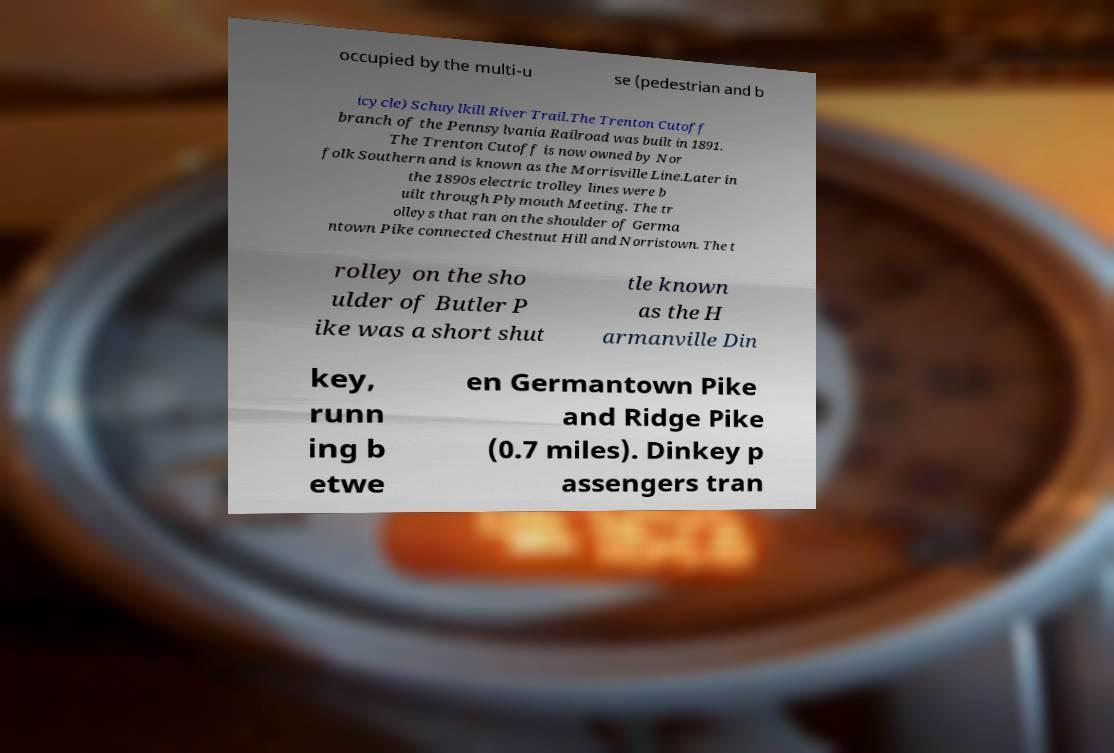I need the written content from this picture converted into text. Can you do that? occupied by the multi-u se (pedestrian and b icycle) Schuylkill River Trail.The Trenton Cutoff branch of the Pennsylvania Railroad was built in 1891. The Trenton Cutoff is now owned by Nor folk Southern and is known as the Morrisville Line.Later in the 1890s electric trolley lines were b uilt through Plymouth Meeting. The tr olleys that ran on the shoulder of Germa ntown Pike connected Chestnut Hill and Norristown. The t rolley on the sho ulder of Butler P ike was a short shut tle known as the H armanville Din key, runn ing b etwe en Germantown Pike and Ridge Pike (0.7 miles). Dinkey p assengers tran 